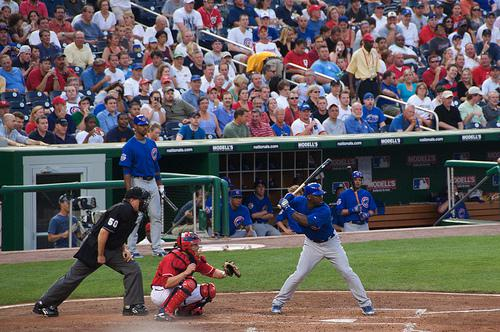Question: why is a man holding a bat?
Choices:
A. To play baseball.
B. To threaten someone.
C. To get loosened up.
D. To hit a ball.
Answer with the letter. Answer: D Question: where was the photo taken?
Choices:
A. At a football game.
B. At skate park.
C. At a baseball game.
D. In the sand dunes.
Answer with the letter. Answer: C Question: what is green?
Choices:
A. Grass.
B. Trees.
C. Flowers.
D. A sign.
Answer with the letter. Answer: A Question: who is wearing black?
Choices:
A. Lady singing.
B. Football player.
C. Catcher.
D. Umpire.
Answer with the letter. Answer: D Question: what is blue?
Choices:
A. Catcher's shirt.
B. Pitcher's shirt.
C. Umpire's shirt.
D. Batter's shirt.
Answer with the letter. Answer: D 